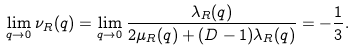<formula> <loc_0><loc_0><loc_500><loc_500>\lim _ { { q } \rightarrow { 0 } } \nu _ { R } ( { q } ) = \lim _ { { q } \rightarrow { 0 } } \frac { \lambda _ { R } ( { q } ) } { 2 \mu _ { R } ( { q } ) + ( D - 1 ) \lambda _ { R } ( { q } ) } = - \frac { 1 } { 3 } .</formula> 